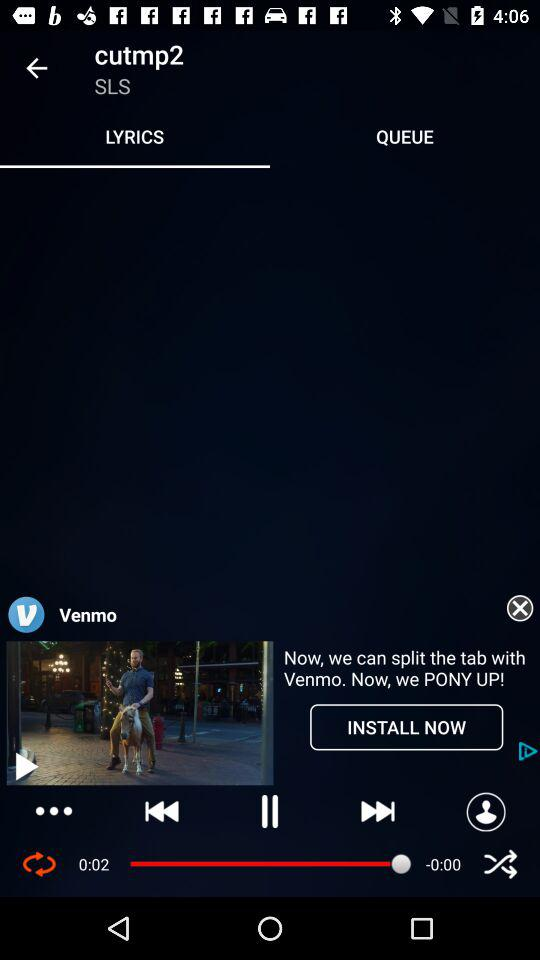What is the selected tab? The selected tab is "LYRICS". 